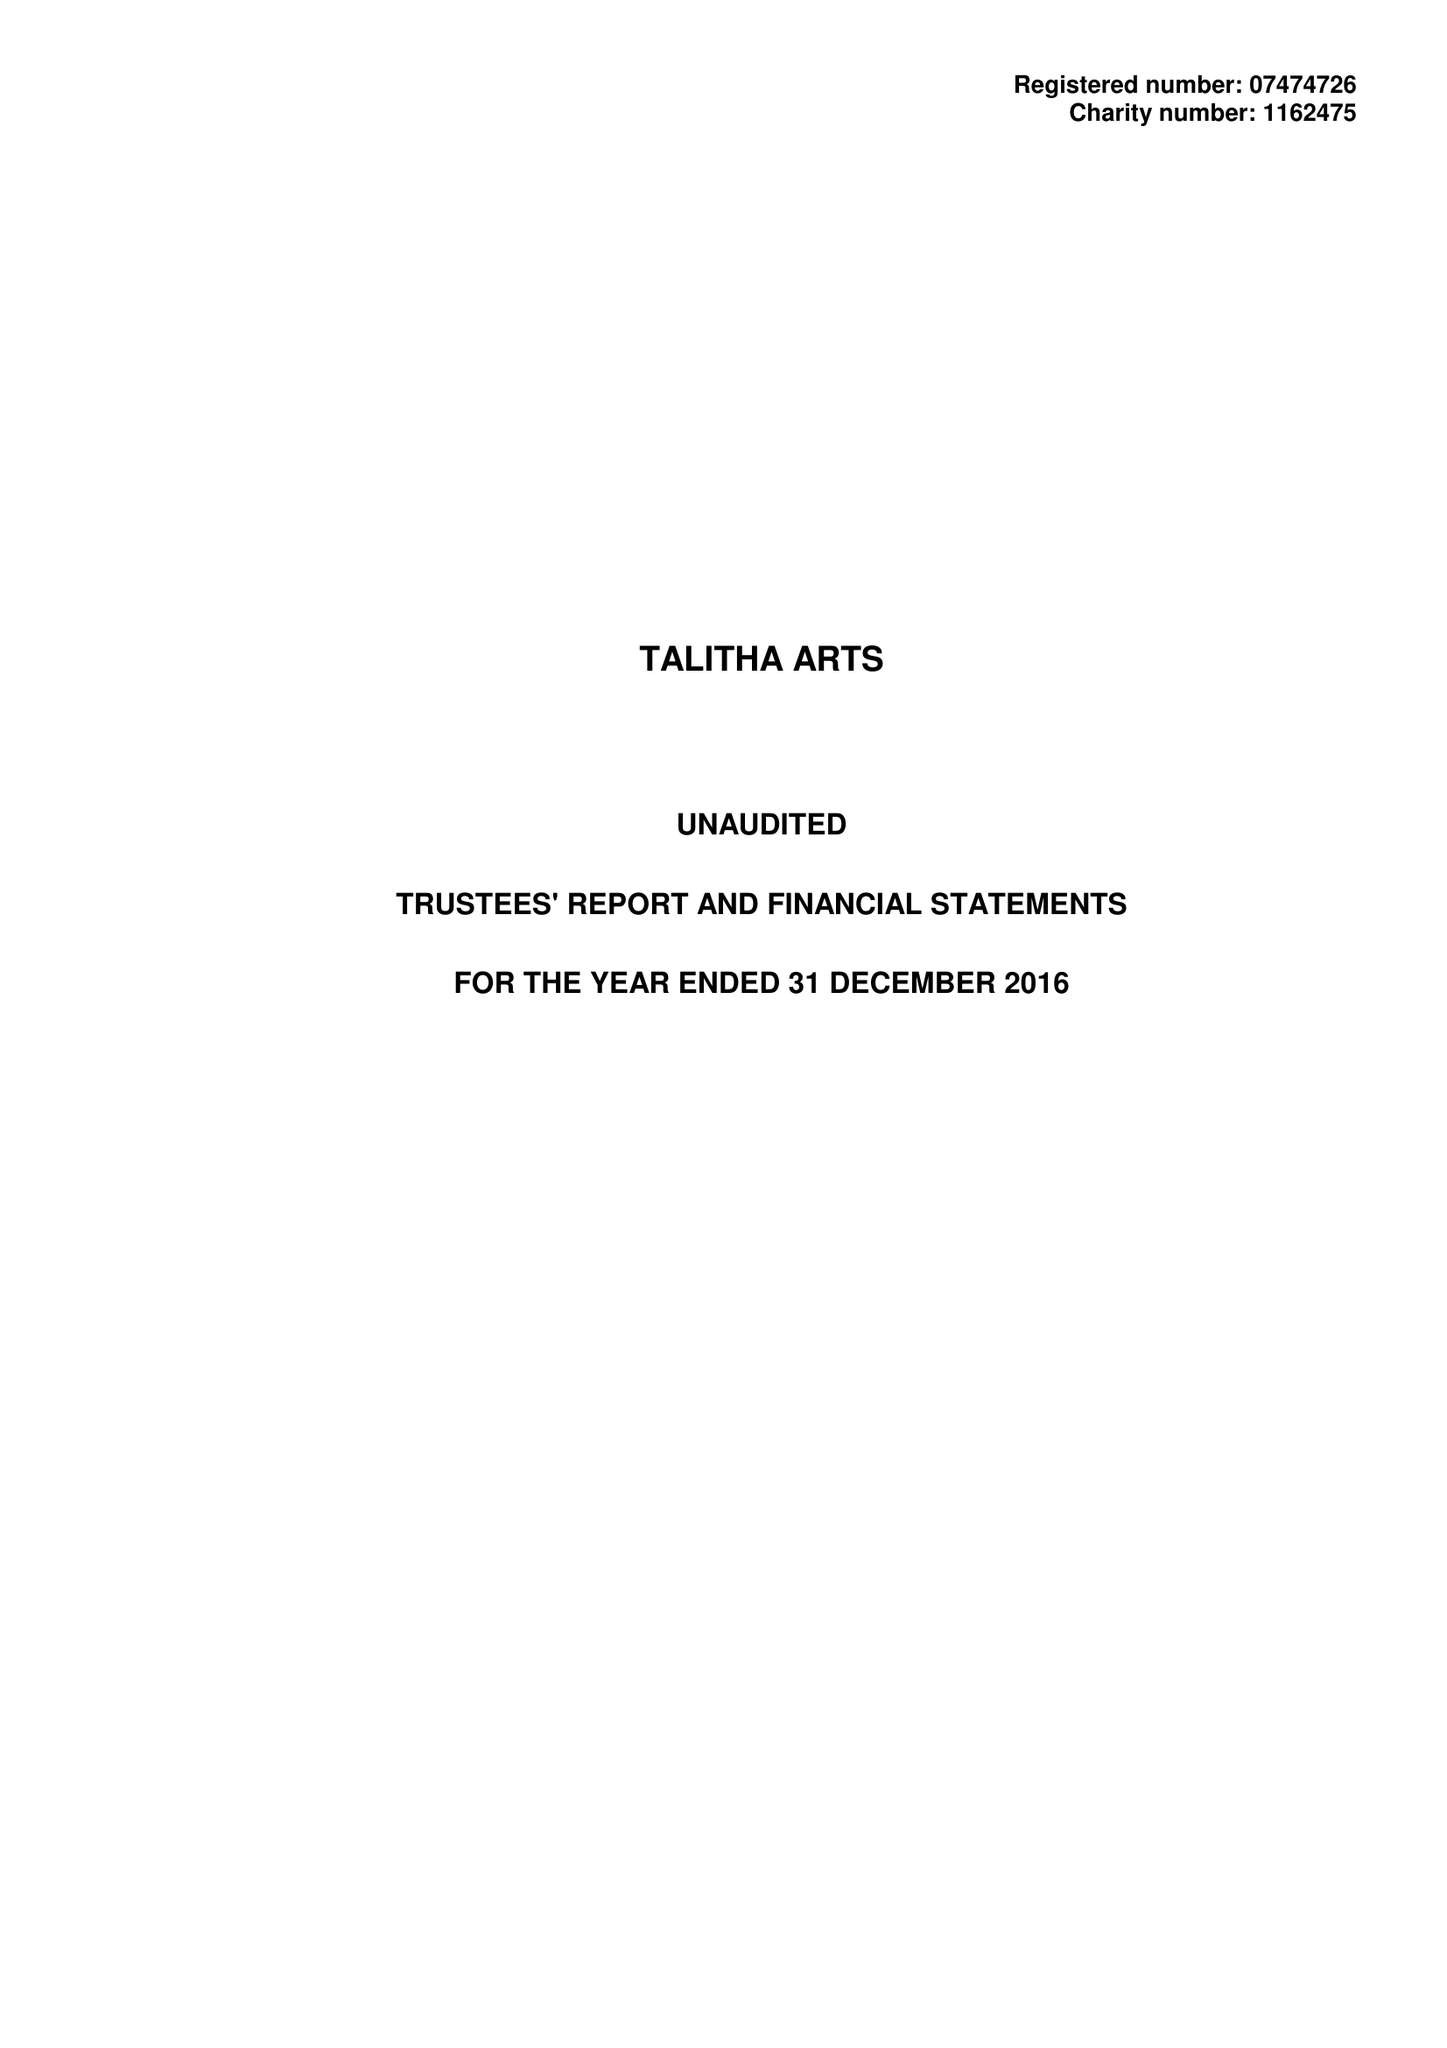What is the value for the income_annually_in_british_pounds?
Answer the question using a single word or phrase. 47100.00 